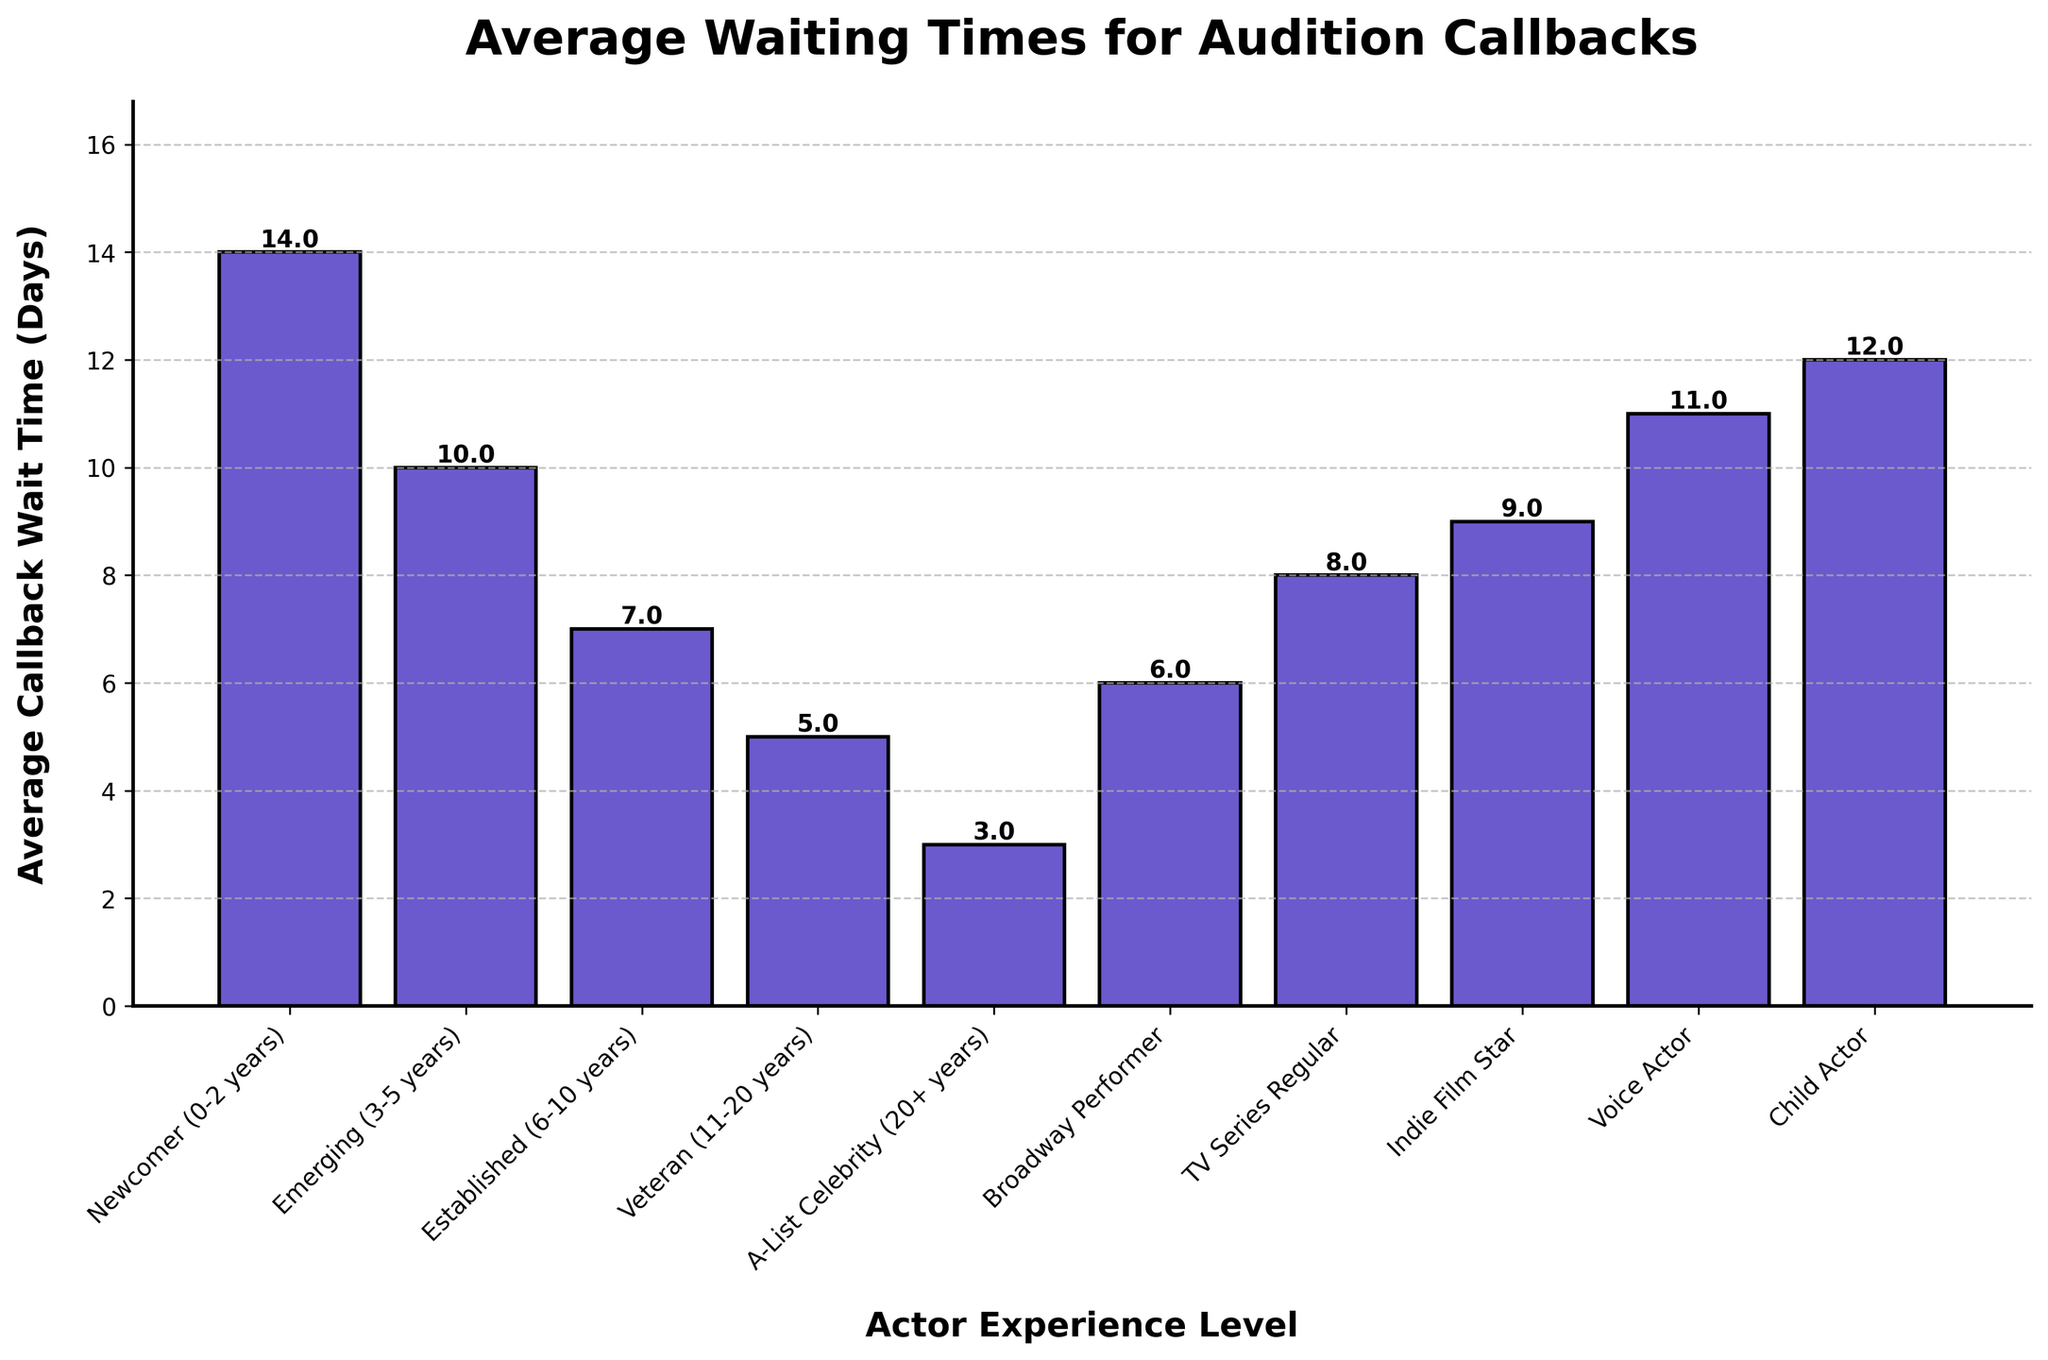Which actor experience level has the shortest average callback wait time? The bar representing the 'A-List Celebrity' experience level is the shortest, indicating the shortest average callback wait time of 3 days.
Answer: A-List Celebrity In total, how many days do 'Newcomer' and 'Emerging' actors spend waiting for callbacks together? The average wait times for 'Newcomer' and 'Emerging' actors are 14 days and 10 days, respectively. The total is 14 + 10 = 24 days.
Answer: 24 days What is the difference in callback wait time between 'Veteran' and 'Indie Film Star'? The 'Veteran' average wait time is 5 days, and the 'Indie Film Star' average wait time is 9 days. The difference is 9 - 5 = 4 days.
Answer: 4 days Which actor experience category has a longer average callback wait time: 'TV Series Regular' or 'Voice Actor'? The bar for 'Voice Actor' is higher than the bar for 'TV Series Regular', indicating a longer average callback wait time of 11 days compared to 8 days.
Answer: Voice Actor Is the average wait time for 'Child Actor' more or less than 'Broadway Performer'? The bar for 'Child Actor' is higher than the bar for 'Broadway Performer', indicating an average callback wait time of 12 days, which is more than 'Broadway Performer's 6 days.
Answer: More Which two experience levels have an identical average callback wait time? By visually comparing the heights of the bars, none of them have identical average callback wait times.
Answer: None Calculate the average callback wait time for actors with over 10 years of experience. The average wait times are as follows: Veteran (5 days) and A-List Celebrity (3 days). The average is (5 + 3)/2 = 4 days.
Answer: 4 days How much longer is the average callback wait time for 'Newcomer' compared to 'Established' actors? The average callback wait times are 14 days for 'Newcomer' and 7 days for 'Established'. The difference is 14 - 7 = 7 days.
Answer: 7 days What is the median average callback wait time across all experience levels? First, sort the average wait times in ascending order: 3, 5, 6, 7, 8, 9, 10, 11, 12, 14. The median is the average of the fifth and sixth values: (8 + 9)/2 = 8.5 days.
Answer: 8.5 days 